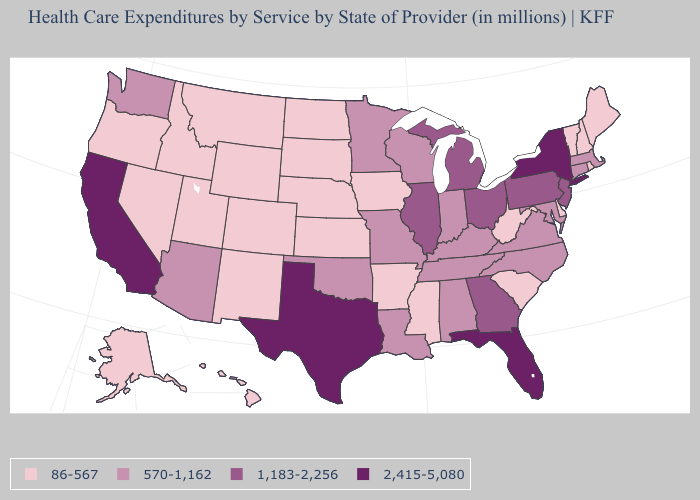What is the lowest value in states that border South Carolina?
Keep it brief. 570-1,162. Among the states that border Illinois , which have the highest value?
Write a very short answer. Indiana, Kentucky, Missouri, Wisconsin. What is the value of Utah?
Short answer required. 86-567. Among the states that border Massachusetts , which have the highest value?
Keep it brief. New York. Name the states that have a value in the range 86-567?
Give a very brief answer. Alaska, Arkansas, Colorado, Delaware, Hawaii, Idaho, Iowa, Kansas, Maine, Mississippi, Montana, Nebraska, Nevada, New Hampshire, New Mexico, North Dakota, Oregon, Rhode Island, South Carolina, South Dakota, Utah, Vermont, West Virginia, Wyoming. Does the first symbol in the legend represent the smallest category?
Quick response, please. Yes. Among the states that border Massachusetts , which have the lowest value?
Answer briefly. New Hampshire, Rhode Island, Vermont. Does Florida have the highest value in the South?
Be succinct. Yes. Among the states that border Arkansas , does Texas have the lowest value?
Write a very short answer. No. Among the states that border Pennsylvania , which have the lowest value?
Write a very short answer. Delaware, West Virginia. What is the lowest value in states that border Pennsylvania?
Quick response, please. 86-567. Name the states that have a value in the range 570-1,162?
Be succinct. Alabama, Arizona, Connecticut, Indiana, Kentucky, Louisiana, Maryland, Massachusetts, Minnesota, Missouri, North Carolina, Oklahoma, Tennessee, Virginia, Washington, Wisconsin. Which states have the lowest value in the MidWest?
Concise answer only. Iowa, Kansas, Nebraska, North Dakota, South Dakota. What is the lowest value in states that border Wyoming?
Short answer required. 86-567. 